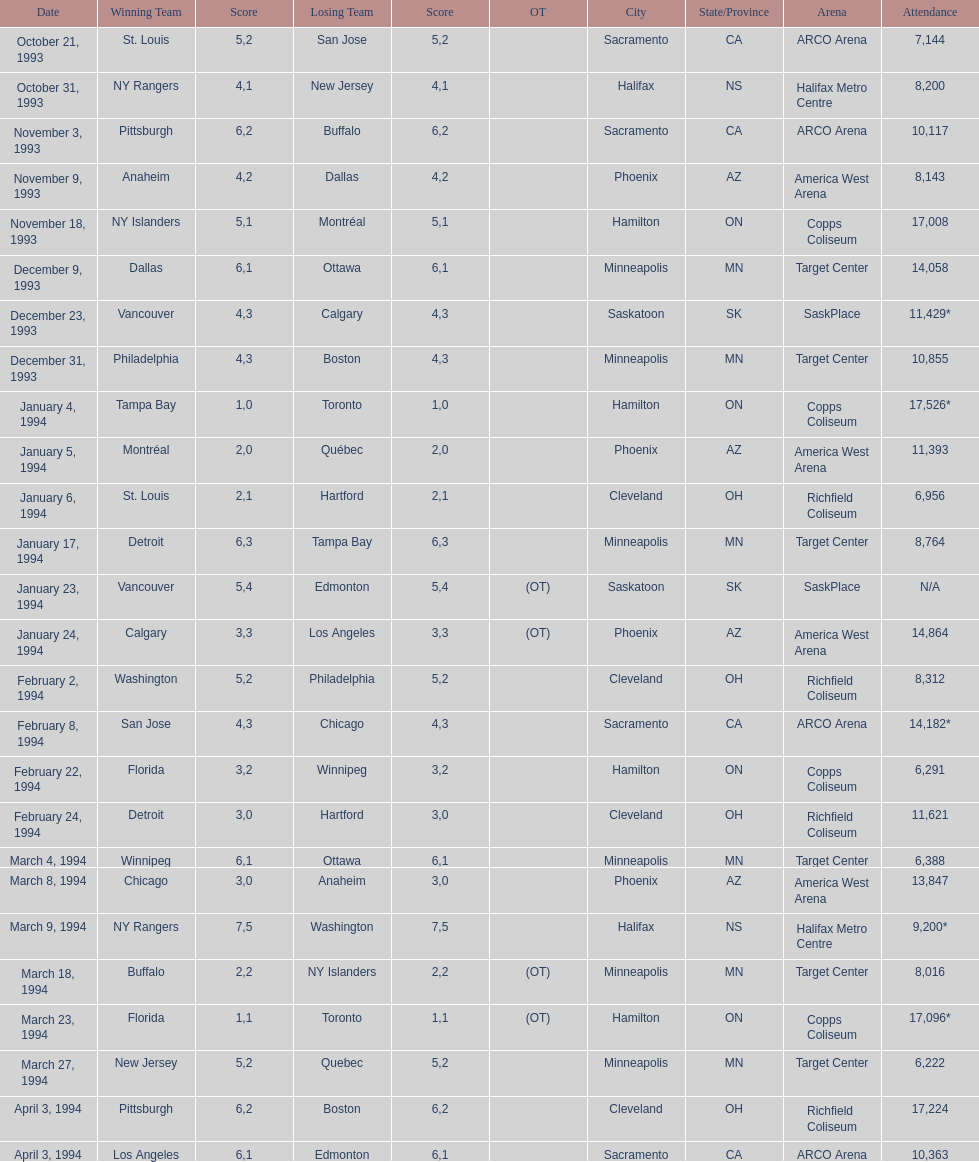Who triumphed in the contest a day before the january 5, 1994 game? Tampa Bay. 